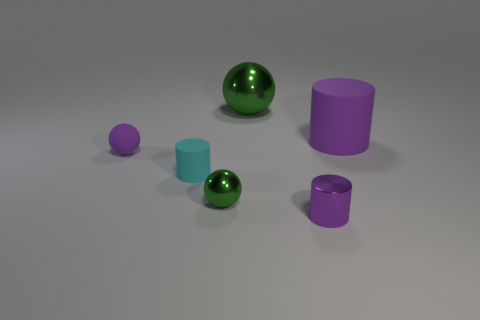Subtract all small cyan rubber cylinders. How many cylinders are left? 2 Add 3 tiny brown cylinders. How many objects exist? 9 Subtract all purple spheres. How many spheres are left? 2 Subtract 0 green blocks. How many objects are left? 6 Subtract 1 cylinders. How many cylinders are left? 2 Subtract all yellow cylinders. Subtract all green cubes. How many cylinders are left? 3 Subtract all purple blocks. How many yellow cylinders are left? 0 Subtract all big red shiny balls. Subtract all large matte things. How many objects are left? 5 Add 1 large purple matte cylinders. How many large purple matte cylinders are left? 2 Add 4 big purple cylinders. How many big purple cylinders exist? 5 